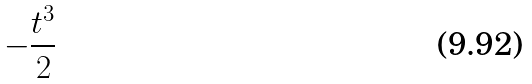Convert formula to latex. <formula><loc_0><loc_0><loc_500><loc_500>- \frac { t ^ { 3 } } { 2 }</formula> 